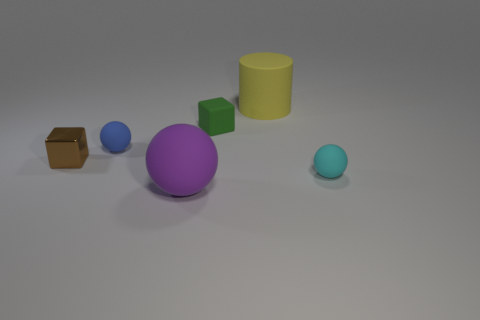Are there any other things that are the same material as the tiny brown cube?
Give a very brief answer. No. There is a cyan thing that is the same size as the brown thing; what shape is it?
Provide a succinct answer. Sphere. Are there any big matte objects that have the same shape as the brown shiny thing?
Provide a succinct answer. No. Does the object in front of the tiny cyan ball have the same material as the small block behind the small brown metallic object?
Provide a succinct answer. Yes. How many big cylinders are the same material as the large yellow thing?
Offer a very short reply. 0. What color is the tiny rubber cube?
Ensure brevity in your answer.  Green. Do the large thing behind the metallic object and the rubber thing to the left of the purple rubber ball have the same shape?
Keep it short and to the point. No. There is a large object that is behind the tiny brown block; what is its color?
Your answer should be compact. Yellow. Is the number of tiny green rubber objects that are to the left of the blue matte object less than the number of small cyan spheres that are left of the green matte object?
Offer a terse response. No. What number of other things are made of the same material as the purple ball?
Your answer should be very brief. 4. 